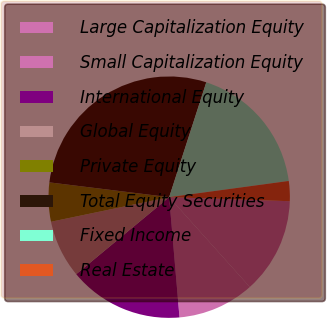<chart> <loc_0><loc_0><loc_500><loc_500><pie_chart><fcel>Large Capitalization Equity<fcel>Small Capitalization Equity<fcel>International Equity<fcel>Global Equity<fcel>Private Equity<fcel>Total Equity Securities<fcel>Fixed Income<fcel>Real Estate<nl><fcel>12.82%<fcel>10.28%<fcel>15.35%<fcel>7.75%<fcel>5.22%<fcel>28.02%<fcel>17.88%<fcel>2.68%<nl></chart> 